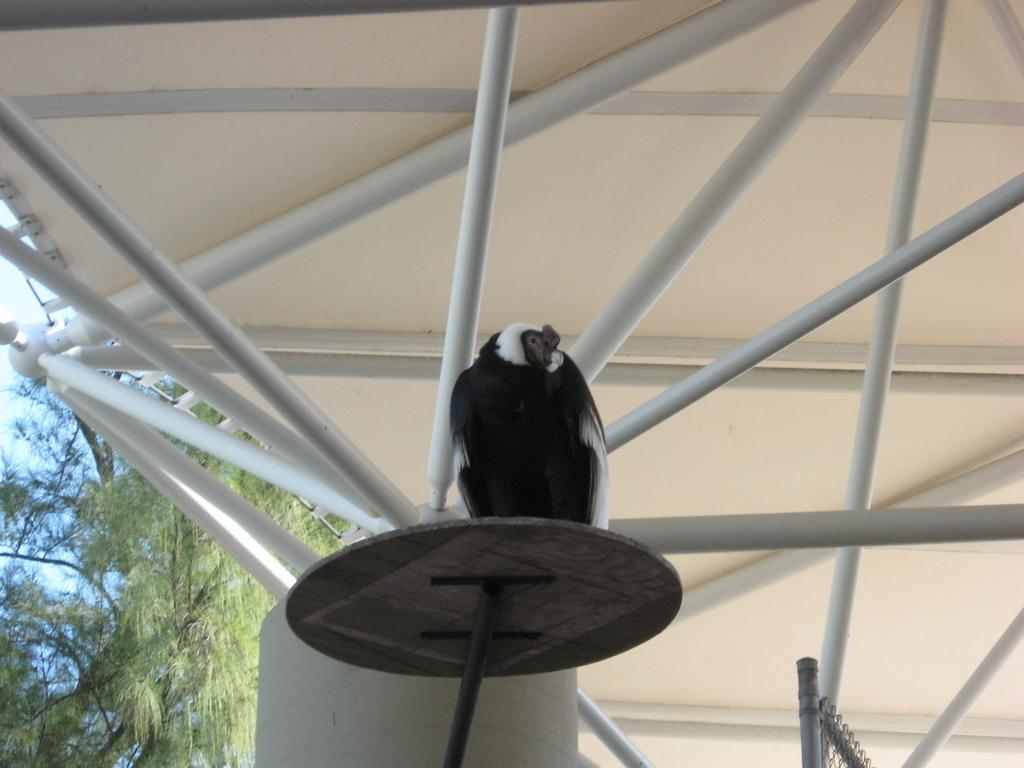What type of animal can be seen in the image? There is a bird in the image. Where is the bird located? The bird is on a round object. What other objects can be seen in the image? There are a few rods in the image. What can be seen in the background of the image? Trees and the sky are visible in the background of the image. What type of shoe is the bird wearing in the image? There is no shoe present in the image, as the bird is not wearing any footwear. What type of business is being conducted in the image? There is no indication of any business activity in the image; it primarily features a bird on a round object. 